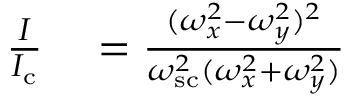Convert formula to latex. <formula><loc_0><loc_0><loc_500><loc_500>\begin{array} { r l } { \frac { I } { I _ { c } } } & = \frac { ( \omega _ { x } ^ { 2 } - \omega _ { y } ^ { 2 } ) ^ { 2 } } { \omega _ { s c } ^ { 2 } ( \omega _ { x } ^ { 2 } + \omega _ { y } ^ { 2 } ) } } \end{array}</formula> 